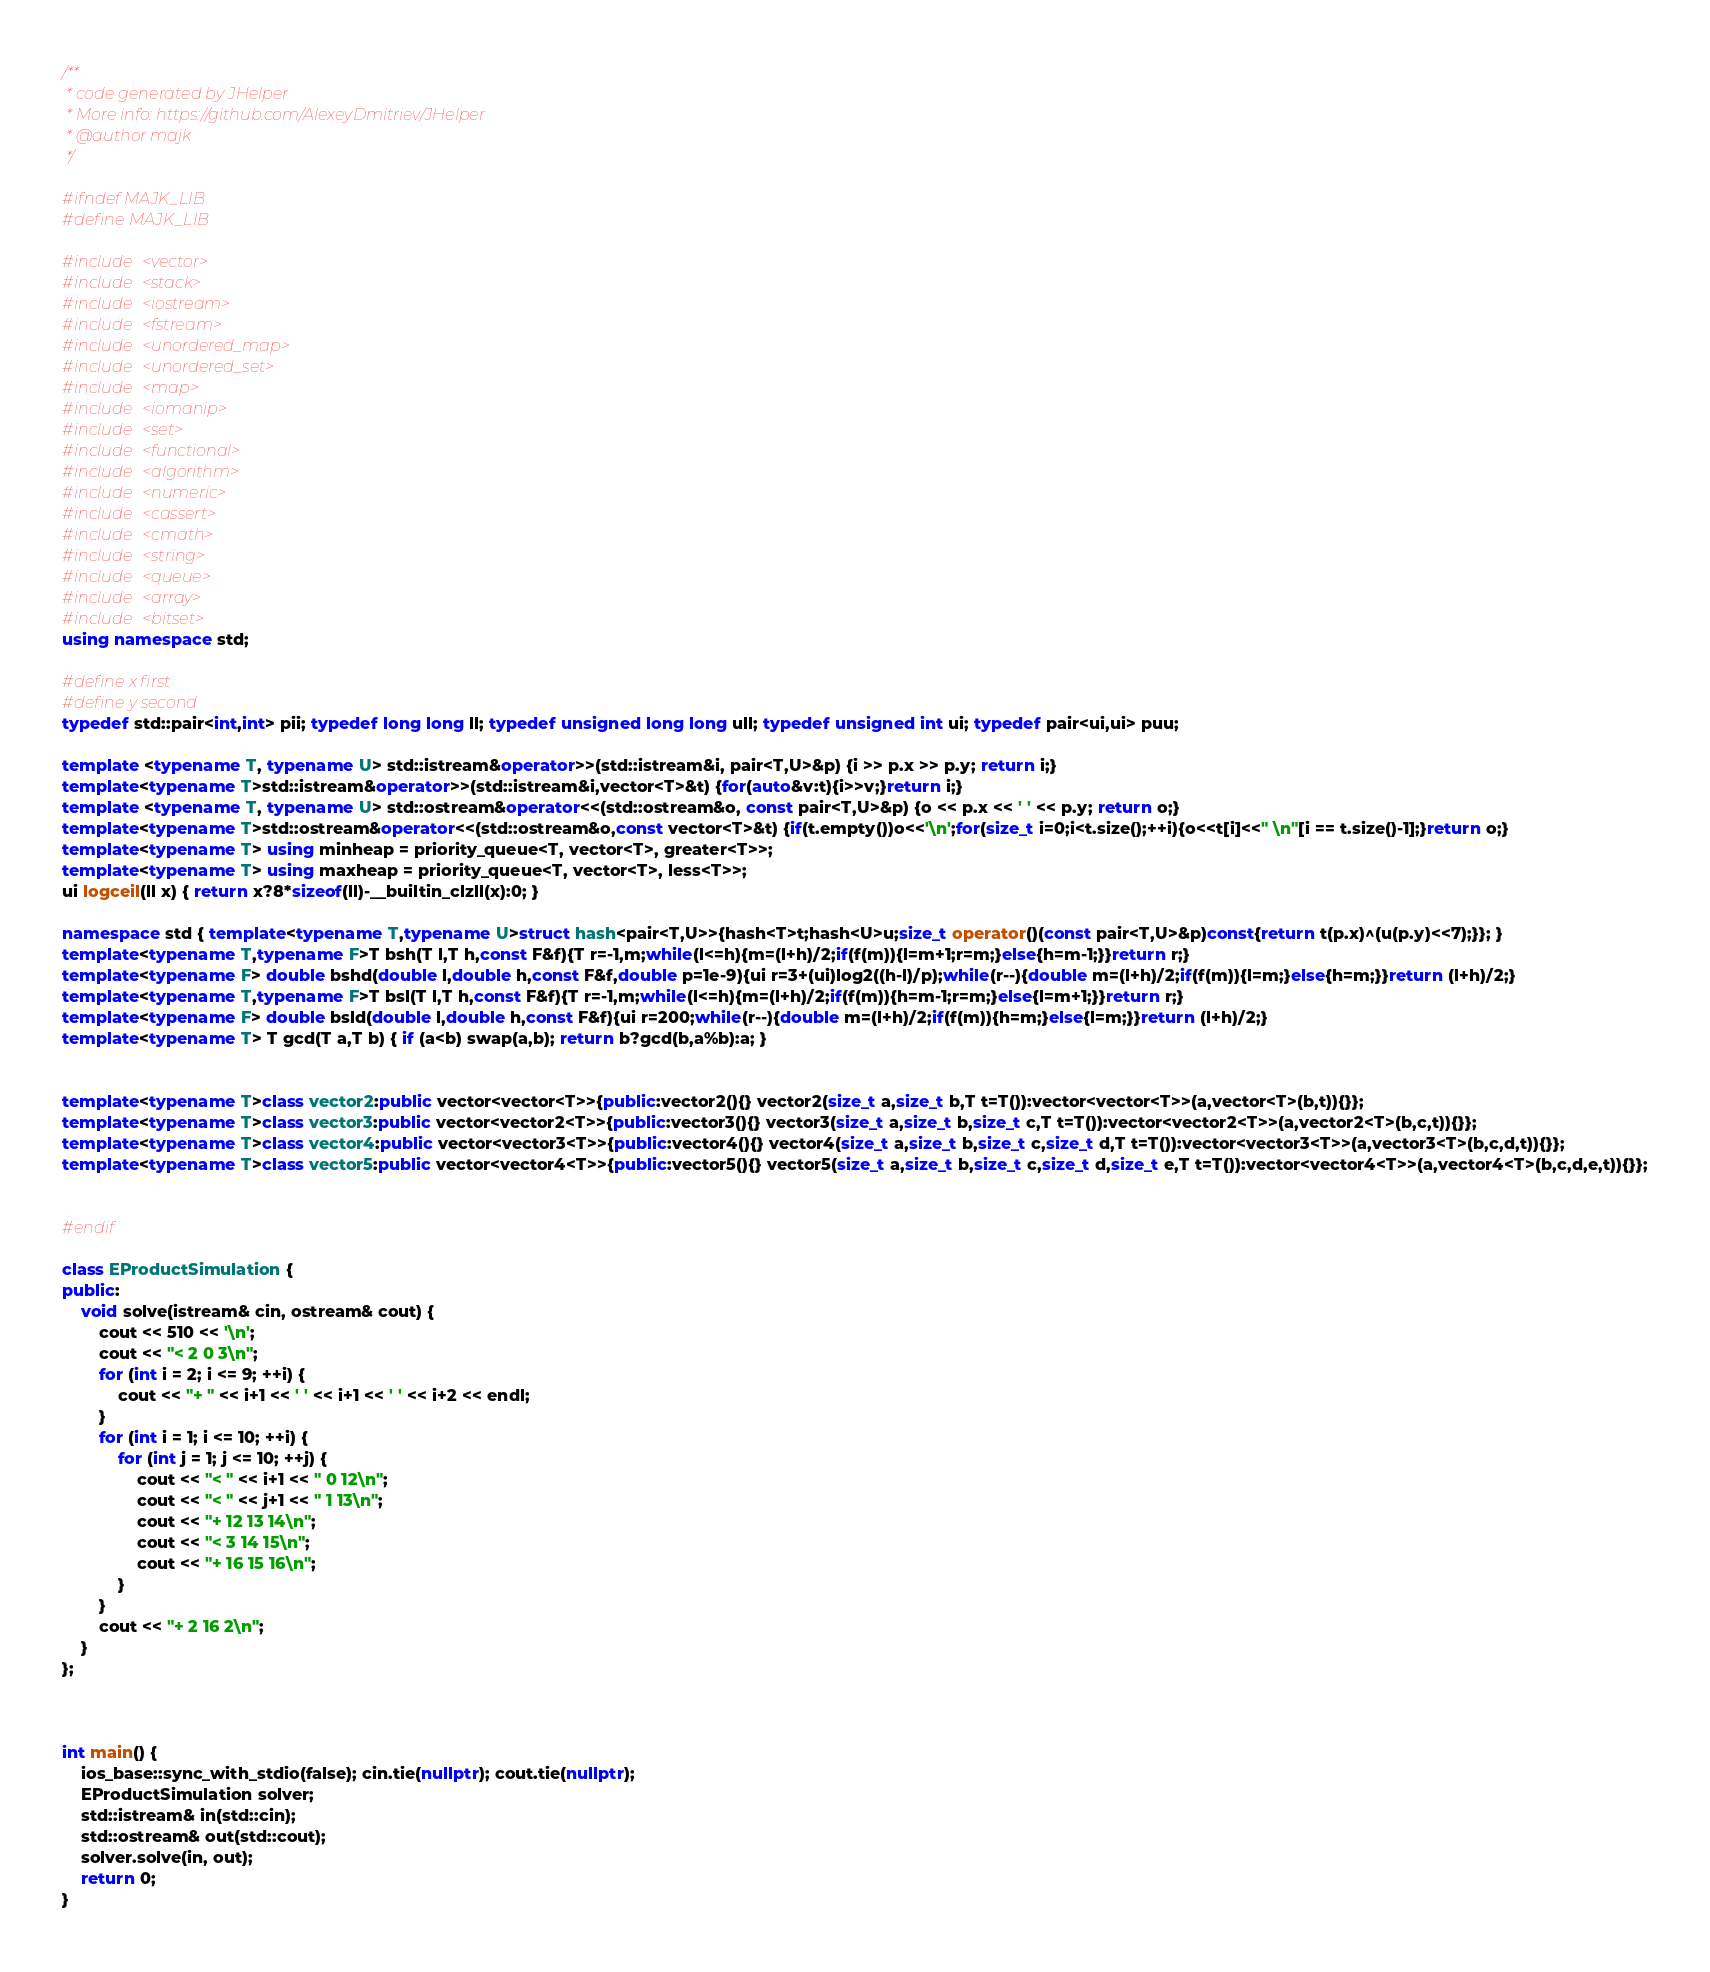<code> <loc_0><loc_0><loc_500><loc_500><_C++_>/**
 * code generated by JHelper
 * More info: https://github.com/AlexeyDmitriev/JHelper
 * @author majk
 */

#ifndef MAJK_LIB
#define MAJK_LIB

#include <vector>
#include <stack>
#include <iostream>
#include <fstream>
#include <unordered_map>
#include <unordered_set>
#include <map>
#include <iomanip>
#include <set>
#include <functional>
#include <algorithm>
#include <numeric>
#include <cassert>
#include <cmath>
#include <string>
#include <queue>
#include <array>
#include <bitset>
using namespace std;

#define x first
#define y second
typedef std::pair<int,int> pii; typedef long long ll; typedef unsigned long long ull; typedef unsigned int ui; typedef pair<ui,ui> puu;

template <typename T, typename U> std::istream&operator>>(std::istream&i, pair<T,U>&p) {i >> p.x >> p.y; return i;}
template<typename T>std::istream&operator>>(std::istream&i,vector<T>&t) {for(auto&v:t){i>>v;}return i;}
template <typename T, typename U> std::ostream&operator<<(std::ostream&o, const pair<T,U>&p) {o << p.x << ' ' << p.y; return o;}
template<typename T>std::ostream&operator<<(std::ostream&o,const vector<T>&t) {if(t.empty())o<<'\n';for(size_t i=0;i<t.size();++i){o<<t[i]<<" \n"[i == t.size()-1];}return o;}
template<typename T> using minheap = priority_queue<T, vector<T>, greater<T>>;
template<typename T> using maxheap = priority_queue<T, vector<T>, less<T>>;
ui logceil(ll x) { return x?8*sizeof(ll)-__builtin_clzll(x):0; }

namespace std { template<typename T,typename U>struct hash<pair<T,U>>{hash<T>t;hash<U>u;size_t operator()(const pair<T,U>&p)const{return t(p.x)^(u(p.y)<<7);}}; }
template<typename T,typename F>T bsh(T l,T h,const F&f){T r=-1,m;while(l<=h){m=(l+h)/2;if(f(m)){l=m+1;r=m;}else{h=m-1;}}return r;}
template<typename F> double bshd(double l,double h,const F&f,double p=1e-9){ui r=3+(ui)log2((h-l)/p);while(r--){double m=(l+h)/2;if(f(m)){l=m;}else{h=m;}}return (l+h)/2;}
template<typename T,typename F>T bsl(T l,T h,const F&f){T r=-1,m;while(l<=h){m=(l+h)/2;if(f(m)){h=m-1;r=m;}else{l=m+1;}}return r;}
template<typename F> double bsld(double l,double h,const F&f){ui r=200;while(r--){double m=(l+h)/2;if(f(m)){h=m;}else{l=m;}}return (l+h)/2;}
template<typename T> T gcd(T a,T b) { if (a<b) swap(a,b); return b?gcd(b,a%b):a; }


template<typename T>class vector2:public vector<vector<T>>{public:vector2(){} vector2(size_t a,size_t b,T t=T()):vector<vector<T>>(a,vector<T>(b,t)){}};
template<typename T>class vector3:public vector<vector2<T>>{public:vector3(){} vector3(size_t a,size_t b,size_t c,T t=T()):vector<vector2<T>>(a,vector2<T>(b,c,t)){}};
template<typename T>class vector4:public vector<vector3<T>>{public:vector4(){} vector4(size_t a,size_t b,size_t c,size_t d,T t=T()):vector<vector3<T>>(a,vector3<T>(b,c,d,t)){}};
template<typename T>class vector5:public vector<vector4<T>>{public:vector5(){} vector5(size_t a,size_t b,size_t c,size_t d,size_t e,T t=T()):vector<vector4<T>>(a,vector4<T>(b,c,d,e,t)){}};


#endif

class EProductSimulation {
public:
    void solve(istream& cin, ostream& cout) {
        cout << 510 << '\n';
        cout << "< 2 0 3\n";
        for (int i = 2; i <= 9; ++i) {
            cout << "+ " << i+1 << ' ' << i+1 << ' ' << i+2 << endl;
        }
        for (int i = 1; i <= 10; ++i) {
            for (int j = 1; j <= 10; ++j) {
                cout << "< " << i+1 << " 0 12\n";
                cout << "< " << j+1 << " 1 13\n";
                cout << "+ 12 13 14\n";
                cout << "< 3 14 15\n";
                cout << "+ 16 15 16\n";
            }
        }
        cout << "+ 2 16 2\n";
    }
};



int main() {
	ios_base::sync_with_stdio(false); cin.tie(nullptr); cout.tie(nullptr);
	EProductSimulation solver;
	std::istream& in(std::cin);
	std::ostream& out(std::cout);
	solver.solve(in, out);
    return 0;
}

</code> 